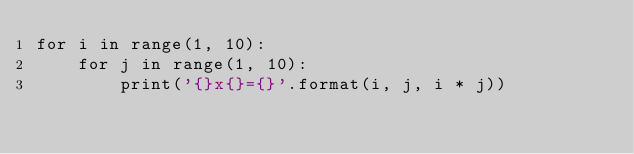<code> <loc_0><loc_0><loc_500><loc_500><_Python_>for i in range(1, 10):
    for j in range(1, 10):
        print('{}x{}={}'.format(i, j, i * j))</code> 